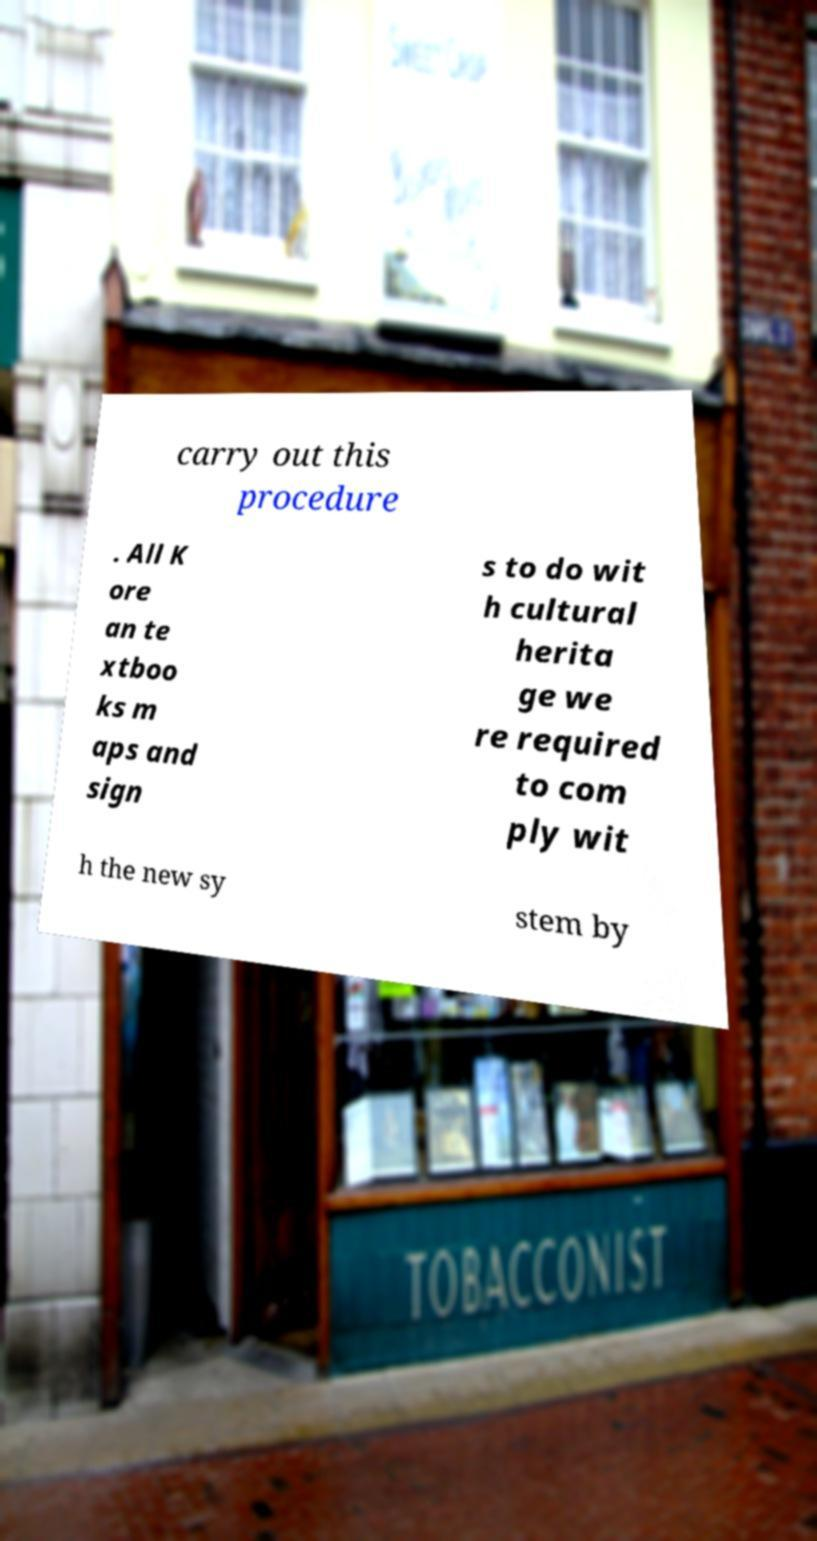Can you accurately transcribe the text from the provided image for me? carry out this procedure . All K ore an te xtboo ks m aps and sign s to do wit h cultural herita ge we re required to com ply wit h the new sy stem by 